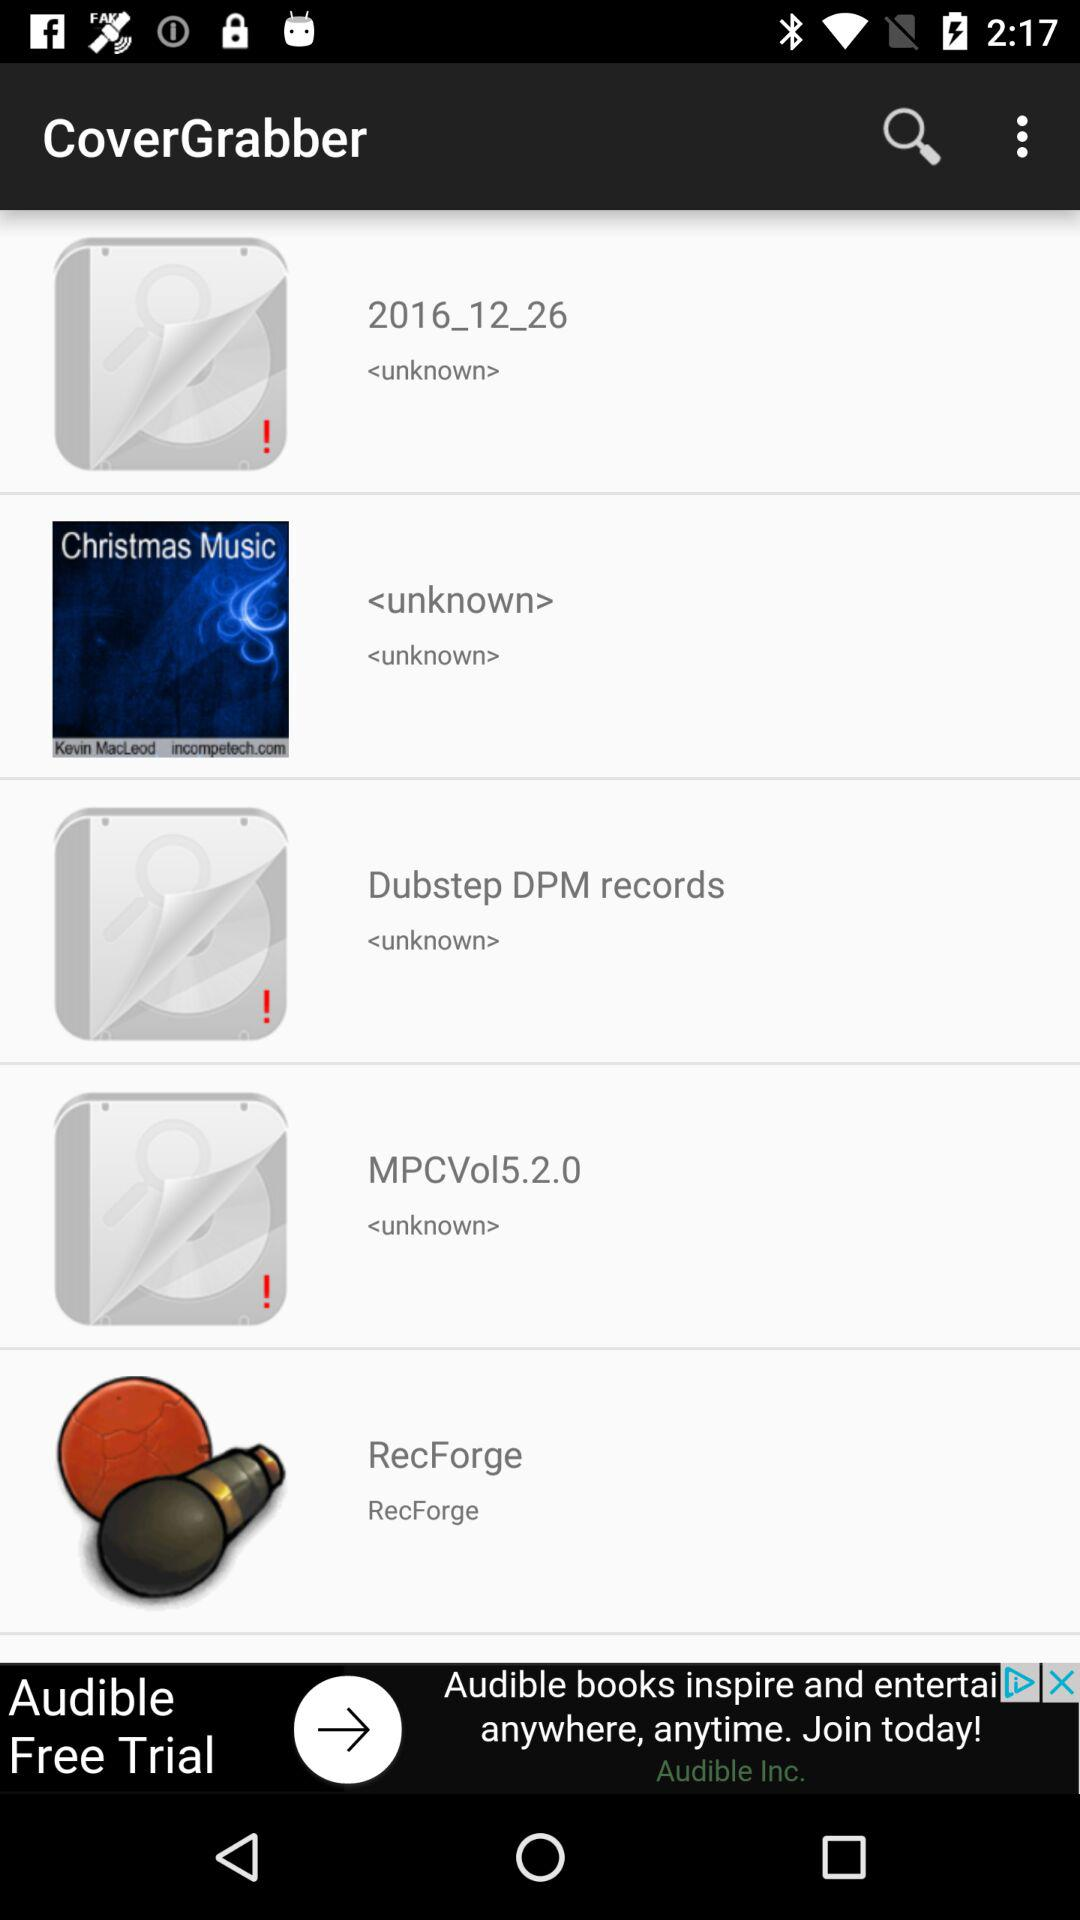How many days does the "Audible" free trial last?
When the provided information is insufficient, respond with <no answer>. <no answer> 